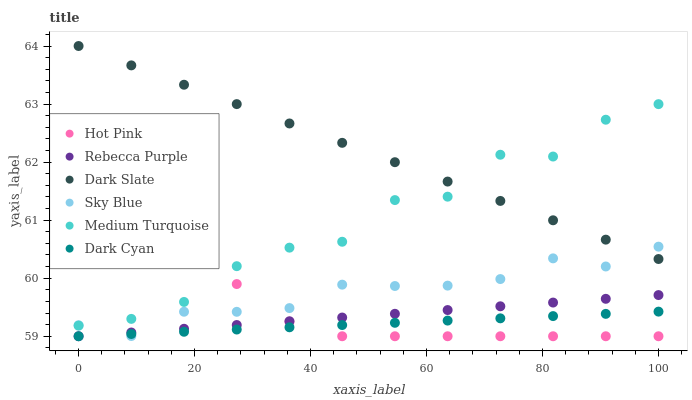Does Dark Cyan have the minimum area under the curve?
Answer yes or no. Yes. Does Dark Slate have the maximum area under the curve?
Answer yes or no. Yes. Does Rebecca Purple have the minimum area under the curve?
Answer yes or no. No. Does Rebecca Purple have the maximum area under the curve?
Answer yes or no. No. Is Dark Cyan the smoothest?
Answer yes or no. Yes. Is Medium Turquoise the roughest?
Answer yes or no. Yes. Is Dark Slate the smoothest?
Answer yes or no. No. Is Dark Slate the roughest?
Answer yes or no. No. Does Hot Pink have the lowest value?
Answer yes or no. Yes. Does Dark Slate have the lowest value?
Answer yes or no. No. Does Dark Slate have the highest value?
Answer yes or no. Yes. Does Rebecca Purple have the highest value?
Answer yes or no. No. Is Dark Cyan less than Dark Slate?
Answer yes or no. Yes. Is Medium Turquoise greater than Dark Cyan?
Answer yes or no. Yes. Does Rebecca Purple intersect Hot Pink?
Answer yes or no. Yes. Is Rebecca Purple less than Hot Pink?
Answer yes or no. No. Is Rebecca Purple greater than Hot Pink?
Answer yes or no. No. Does Dark Cyan intersect Dark Slate?
Answer yes or no. No. 